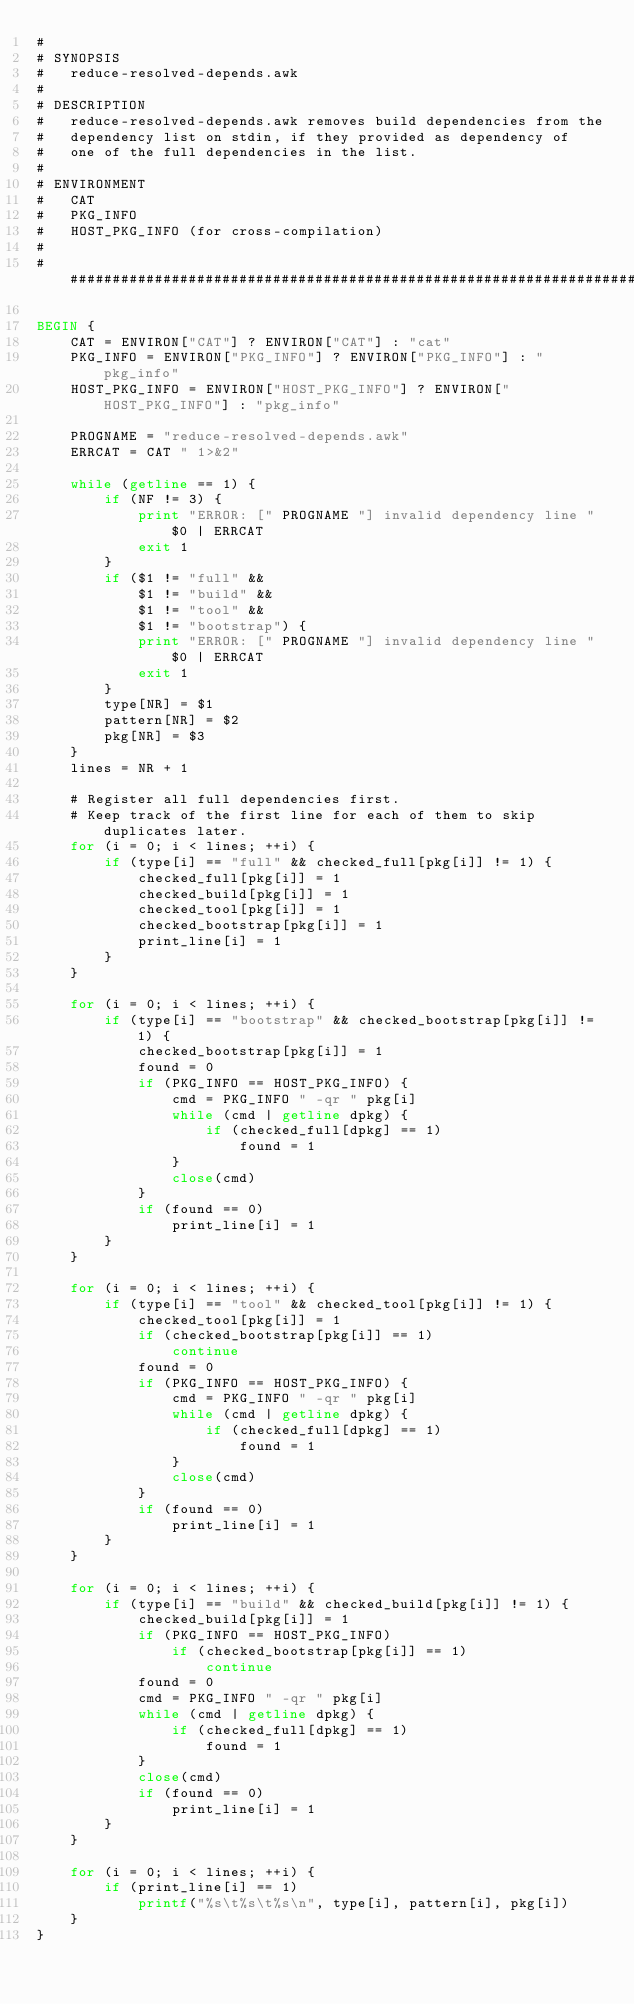<code> <loc_0><loc_0><loc_500><loc_500><_Awk_>#
# SYNOPSIS
#	reduce-resolved-depends.awk
#
# DESCRIPTION
#	reduce-resolved-depends.awk removes build dependencies from the
#	dependency list on stdin, if they provided as dependency of
#	one of the full dependencies in the list.
#
# ENVIRONMENT
#	CAT
#	PKG_INFO
#	HOST_PKG_INFO (for cross-compilation)
#
######################################################################

BEGIN {
	CAT = ENVIRON["CAT"] ? ENVIRON["CAT"] : "cat"
	PKG_INFO = ENVIRON["PKG_INFO"] ? ENVIRON["PKG_INFO"] : "pkg_info"
	HOST_PKG_INFO = ENVIRON["HOST_PKG_INFO"] ? ENVIRON["HOST_PKG_INFO"] : "pkg_info"

	PROGNAME = "reduce-resolved-depends.awk"
	ERRCAT = CAT " 1>&2"

	while (getline == 1) {
		if (NF != 3) {
			print "ERROR: [" PROGNAME "] invalid dependency line " $0 | ERRCAT
			exit 1
		}
		if ($1 != "full" &&
		    $1 != "build" &&
		    $1 != "tool" &&
		    $1 != "bootstrap") {
			print "ERROR: [" PROGNAME "] invalid dependency line " $0 | ERRCAT
			exit 1
		}
		type[NR] = $1
		pattern[NR] = $2
		pkg[NR] = $3
	}
	lines = NR + 1

	# Register all full dependencies first.
	# Keep track of the first line for each of them to skip duplicates later.
	for (i = 0; i < lines; ++i) {
		if (type[i] == "full" && checked_full[pkg[i]] != 1) {
			checked_full[pkg[i]] = 1
			checked_build[pkg[i]] = 1
			checked_tool[pkg[i]] = 1
			checked_bootstrap[pkg[i]] = 1
			print_line[i] = 1
		}
	}

	for (i = 0; i < lines; ++i) {
		if (type[i] == "bootstrap" && checked_bootstrap[pkg[i]] != 1) {
			checked_bootstrap[pkg[i]] = 1
			found = 0
			if (PKG_INFO == HOST_PKG_INFO) {
				cmd = PKG_INFO " -qr " pkg[i]
				while (cmd | getline dpkg) {
					if (checked_full[dpkg] == 1)
						found = 1
				}
				close(cmd)
			}
			if (found == 0)
				print_line[i] = 1
		}
	}

	for (i = 0; i < lines; ++i) {
		if (type[i] == "tool" && checked_tool[pkg[i]] != 1) {
			checked_tool[pkg[i]] = 1
			if (checked_bootstrap[pkg[i]] == 1)
				continue
			found = 0
			if (PKG_INFO == HOST_PKG_INFO) {
				cmd = PKG_INFO " -qr " pkg[i]
				while (cmd | getline dpkg) {
					if (checked_full[dpkg] == 1)
						found = 1
				}
				close(cmd)
			}
			if (found == 0)
				print_line[i] = 1
		}
	}

	for (i = 0; i < lines; ++i) {
		if (type[i] == "build" && checked_build[pkg[i]] != 1) {
			checked_build[pkg[i]] = 1
			if (PKG_INFO == HOST_PKG_INFO)
				if (checked_bootstrap[pkg[i]] == 1)
					continue
			found = 0
			cmd = PKG_INFO " -qr " pkg[i]
			while (cmd | getline dpkg) {
				if (checked_full[dpkg] == 1)
					found = 1
			}
			close(cmd)
			if (found == 0)
				print_line[i] = 1
		}
	}

	for (i = 0; i < lines; ++i) {
		if (print_line[i] == 1)
			printf("%s\t%s\t%s\n", type[i], pattern[i], pkg[i])
	}
}
</code> 